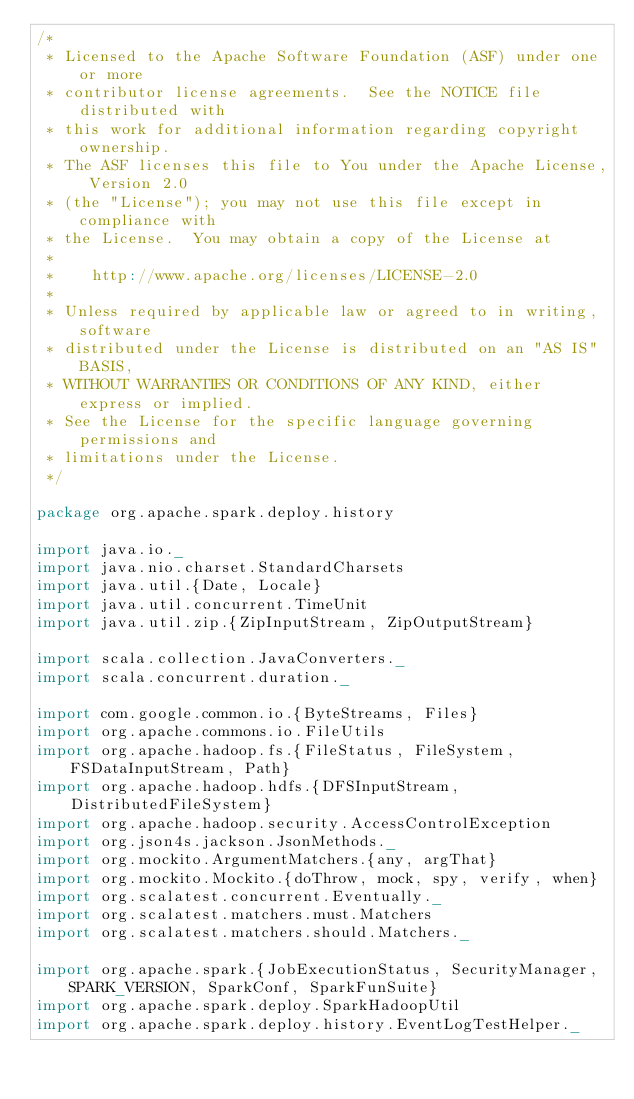<code> <loc_0><loc_0><loc_500><loc_500><_Scala_>/*
 * Licensed to the Apache Software Foundation (ASF) under one or more
 * contributor license agreements.  See the NOTICE file distributed with
 * this work for additional information regarding copyright ownership.
 * The ASF licenses this file to You under the Apache License, Version 2.0
 * (the "License"); you may not use this file except in compliance with
 * the License.  You may obtain a copy of the License at
 *
 *    http://www.apache.org/licenses/LICENSE-2.0
 *
 * Unless required by applicable law or agreed to in writing, software
 * distributed under the License is distributed on an "AS IS" BASIS,
 * WITHOUT WARRANTIES OR CONDITIONS OF ANY KIND, either express or implied.
 * See the License for the specific language governing permissions and
 * limitations under the License.
 */

package org.apache.spark.deploy.history

import java.io._
import java.nio.charset.StandardCharsets
import java.util.{Date, Locale}
import java.util.concurrent.TimeUnit
import java.util.zip.{ZipInputStream, ZipOutputStream}

import scala.collection.JavaConverters._
import scala.concurrent.duration._

import com.google.common.io.{ByteStreams, Files}
import org.apache.commons.io.FileUtils
import org.apache.hadoop.fs.{FileStatus, FileSystem, FSDataInputStream, Path}
import org.apache.hadoop.hdfs.{DFSInputStream, DistributedFileSystem}
import org.apache.hadoop.security.AccessControlException
import org.json4s.jackson.JsonMethods._
import org.mockito.ArgumentMatchers.{any, argThat}
import org.mockito.Mockito.{doThrow, mock, spy, verify, when}
import org.scalatest.concurrent.Eventually._
import org.scalatest.matchers.must.Matchers
import org.scalatest.matchers.should.Matchers._

import org.apache.spark.{JobExecutionStatus, SecurityManager, SPARK_VERSION, SparkConf, SparkFunSuite}
import org.apache.spark.deploy.SparkHadoopUtil
import org.apache.spark.deploy.history.EventLogTestHelper._</code> 